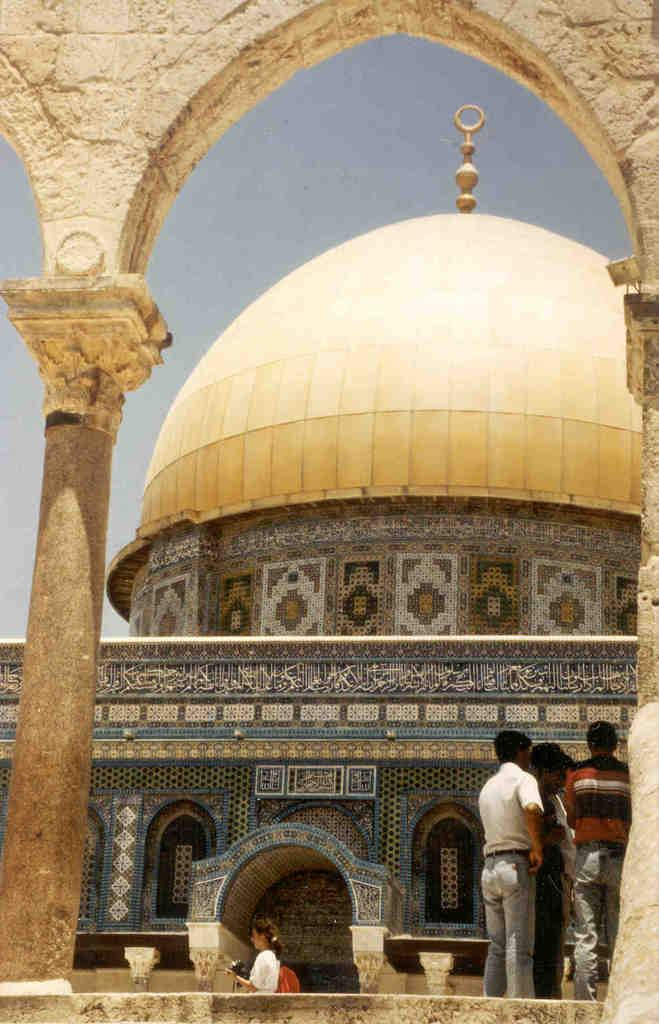What is the main structure in the center of the image? There is a mosque in the center of the image. Can you describe the people in the image? There are people in the image, but their specific actions or positions are not mentioned in the facts. What architectural features are present in the foreground of the image? There are pillars and a wall in the foreground of the image. What is visible at the top of the image? The sky is visible at the top of the image. How many yaks are grazing in the foreground of the image? There are no yaks present in the image; it features a mosque, people, pillars, and a wall. What type of underwear are the people wearing in the image? There is no information about the clothing or underwear of the people in the image. 